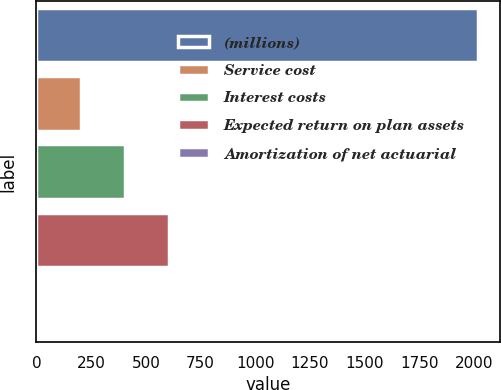Convert chart. <chart><loc_0><loc_0><loc_500><loc_500><bar_chart><fcel>(millions)<fcel>Service cost<fcel>Interest costs<fcel>Expected return on plan assets<fcel>Amortization of net actuarial<nl><fcel>2018<fcel>204.32<fcel>405.84<fcel>607.36<fcel>2.8<nl></chart> 